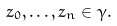Convert formula to latex. <formula><loc_0><loc_0><loc_500><loc_500>z _ { 0 } , \dots , z _ { n } \in \gamma .</formula> 